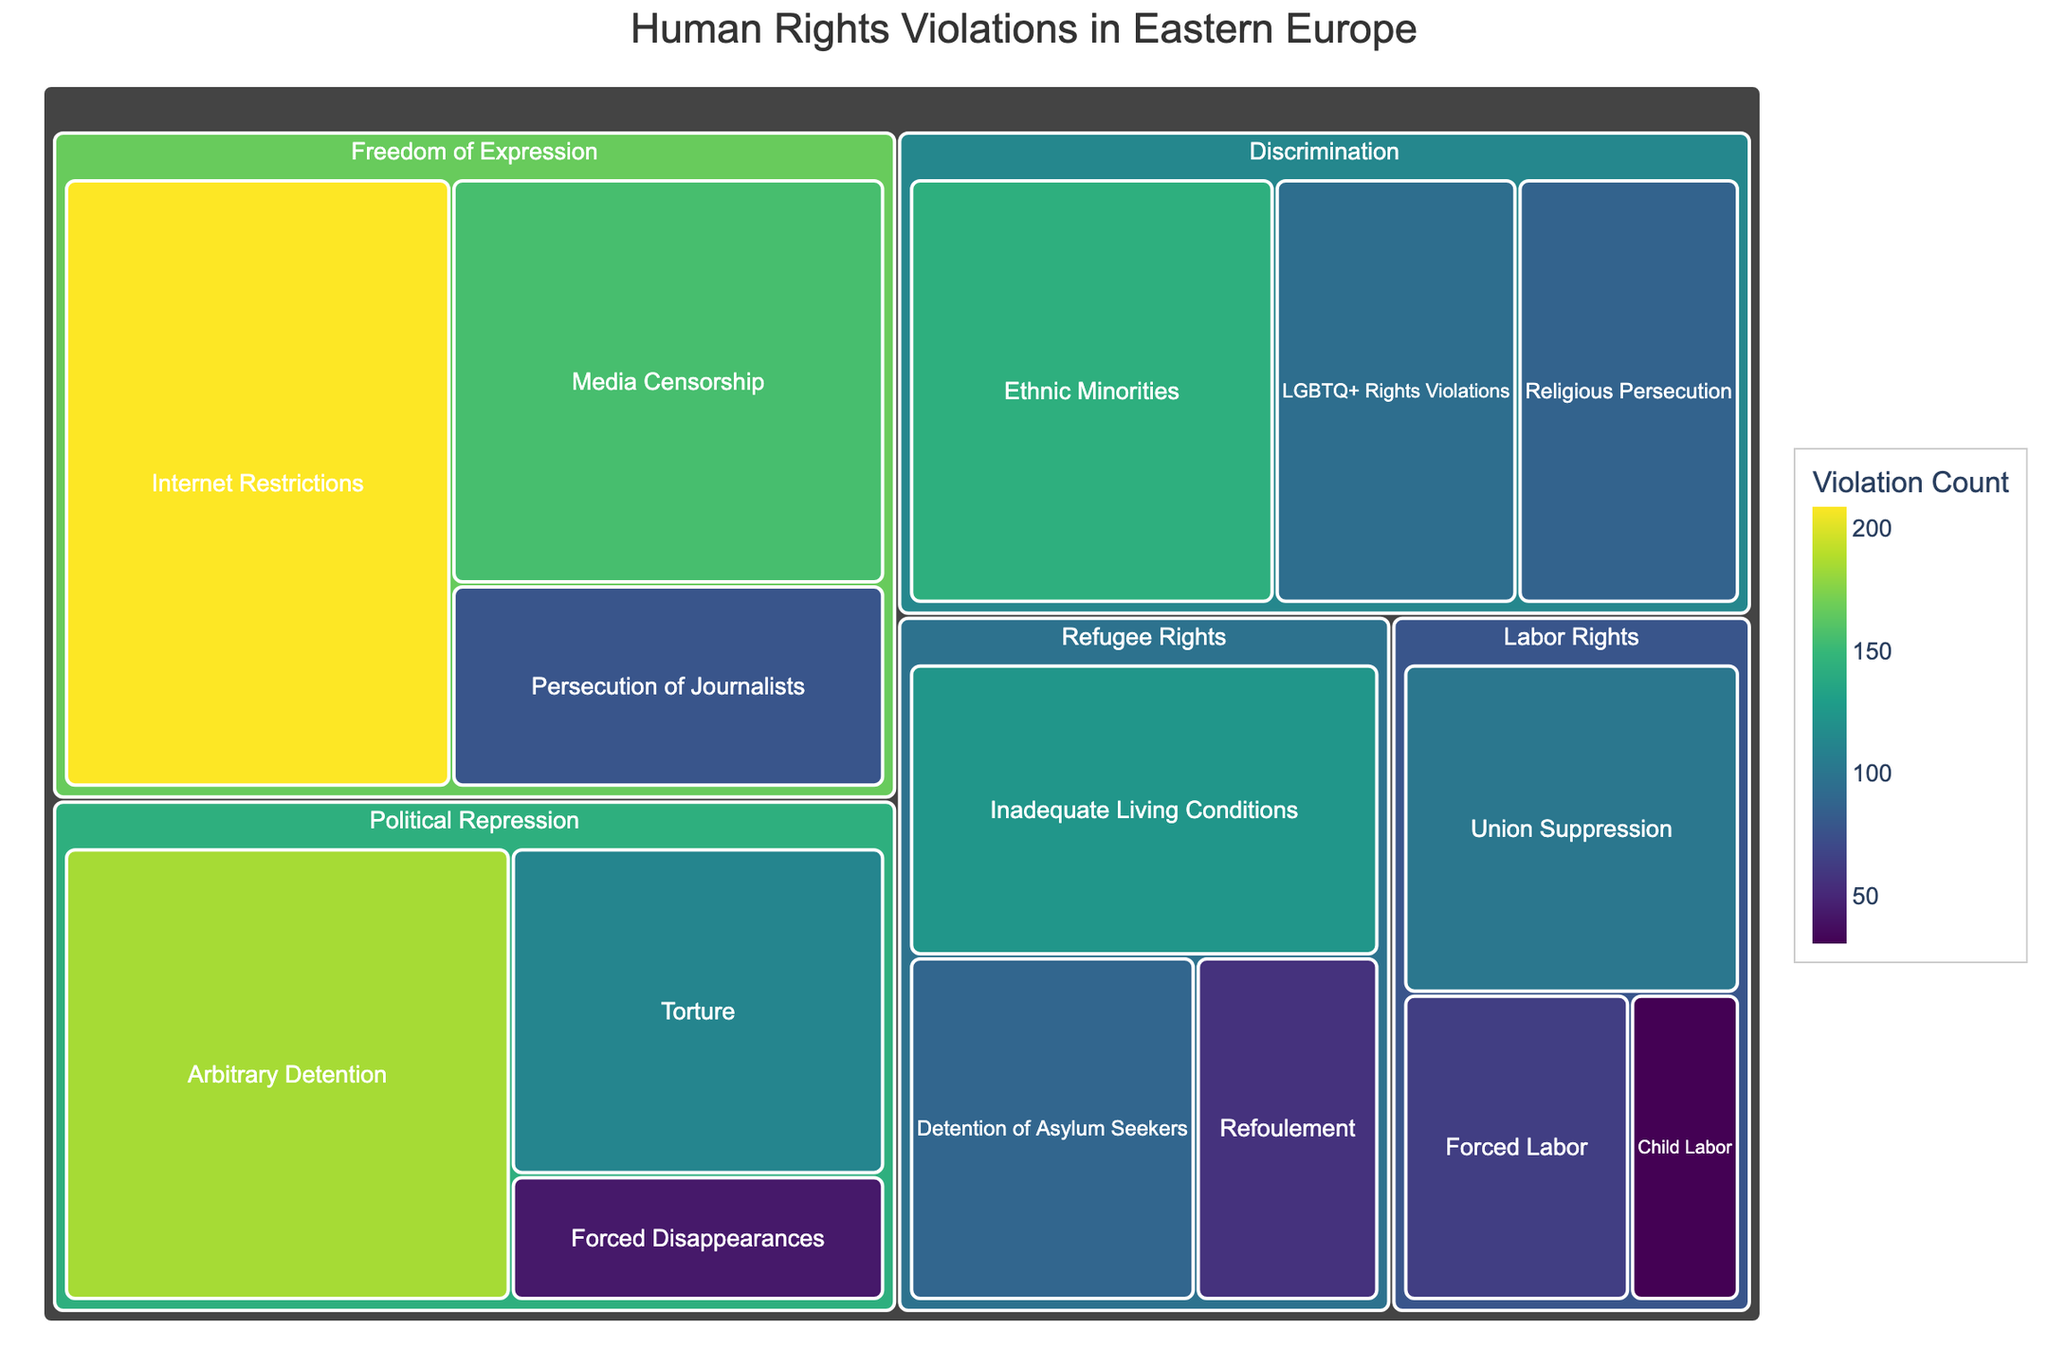what is the title of the Treemap? The title of the Treemap is usually prominently displayed at the top of the figure. It helps viewers understand the purpose of the visualization.
Answer: Human Rights Violations in Eastern Europe Which subcategory has the highest count within the 'Freedom of Expression' category? By looking at the 'Freedom of Expression' category, we can identify the subcategory with the largest tile and highest value.
Answer: Internet Restrictions Add up the counts of all subcategories under 'Political Repression' and provide the total. We need to sum the values of all subcategories under 'Political Repression': Arbitrary Detention (185), Forced Disappearances (43), and Torture (112). Total = 185 + 43 + 112.
Answer: 340 Which category shows the highest weighted count of violations and what is that count? By comparing the overall values of the tiles of each primary category, we note which one has the largest total value represented visually and numerically.
Answer: Freedom of Expression, 443 Compare the count of 'Forced Labor' with 'Union Suppression' and state which one is higher. By examining the values of the 'Forced Labor' and 'Union Suppression' subcategories directly, we compare these two numbers. Forced Labor has 64, and Union Suppression has 102.
Answer: Union Suppression How do the values of 'Ethnic Minorities' and 'LGBTQ+ Rights Violations' compare in the 'Discrimination' category? We identify the values of 'Ethnic Minorities' (143) and 'LGBTQ+ Rights Violations' (95) and compare them to see which is larger.
Answer: Ethnic Minorities What is the average value of counts within the 'Labor Rights' category? Sum the values of 'Forced Labor' (64), 'Child Labor' (31), and 'Union Suppression' (102) to get the total, then divide by the number of subcategories (3). Average = (64 + 31 + 102) / 3.
Answer: 65.7 Identify the subcategory with the lowest number of violations within 'Refugee Rights'. Within the 'Refugee Rights' category, we look for the subcategory with the smallest numerical value amongst 'Refoulement' (57), 'Detention of Asylum Seekers' (89), and 'Inadequate Living Conditions' (124).
Answer: Refoulement What is the difference in the count of 'Media Censorship' and 'Persecution of Journalists' within the 'Freedom of Expression' category? Subtract the value of 'Persecution of Journalists' (78) from 'Media Censorship' (156). Difference = 156 - 78.
Answer: 78 What subcategory has the highest count in the entire Treemap? By visually inspecting the largest tile with the highest numerical value in the Treemap overall, we find which subcategory has the highest count.
Answer: Internet Restrictions 